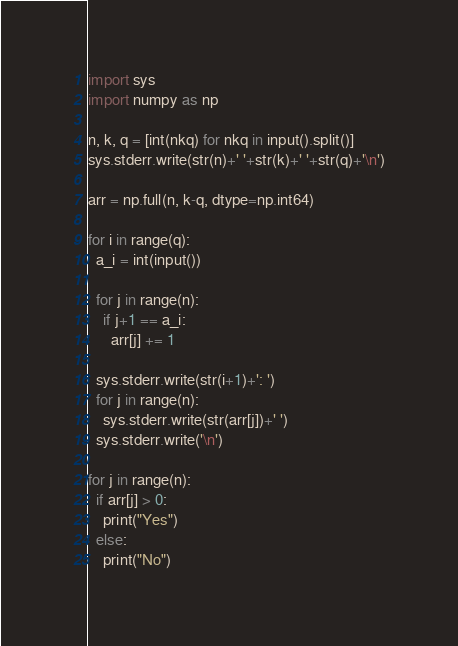Convert code to text. <code><loc_0><loc_0><loc_500><loc_500><_Python_>import sys
import numpy as np

n, k, q = [int(nkq) for nkq in input().split()]
sys.stderr.write(str(n)+' '+str(k)+' '+str(q)+'\n')

arr = np.full(n, k-q, dtype=np.int64)

for i in range(q):
  a_i = int(input())
  
  for j in range(n):
    if j+1 == a_i:
      arr[j] += 1

  sys.stderr.write(str(i+1)+': ')
  for j in range(n):
    sys.stderr.write(str(arr[j])+' ')
  sys.stderr.write('\n')

for j in range(n):
  if arr[j] > 0:
    print("Yes")
  else:
    print("No")
</code> 